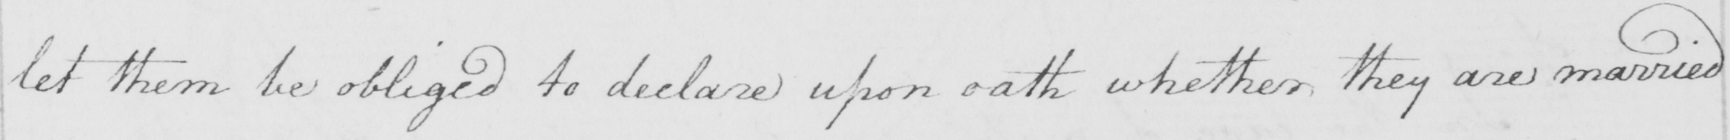Can you read and transcribe this handwriting? let them be obliged to declare upon oath whether they are married 